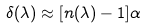<formula> <loc_0><loc_0><loc_500><loc_500>\delta ( \lambda ) \approx [ n ( \lambda ) - 1 ] \alpha</formula> 